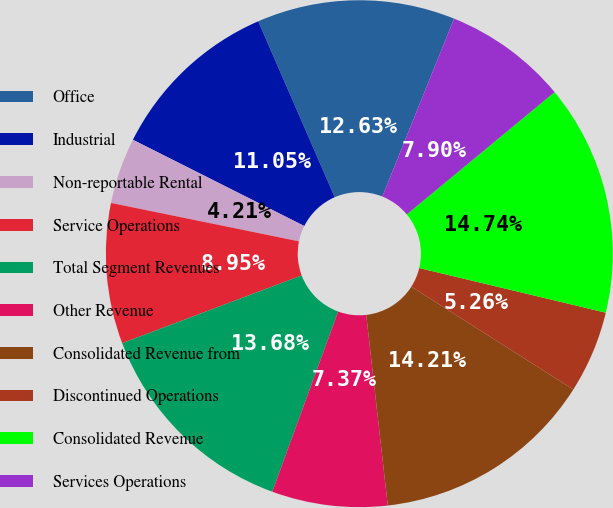<chart> <loc_0><loc_0><loc_500><loc_500><pie_chart><fcel>Office<fcel>Industrial<fcel>Non-reportable Rental<fcel>Service Operations<fcel>Total Segment Revenues<fcel>Other Revenue<fcel>Consolidated Revenue from<fcel>Discontinued Operations<fcel>Consolidated Revenue<fcel>Services Operations<nl><fcel>12.63%<fcel>11.05%<fcel>4.21%<fcel>8.95%<fcel>13.68%<fcel>7.37%<fcel>14.21%<fcel>5.26%<fcel>14.74%<fcel>7.9%<nl></chart> 